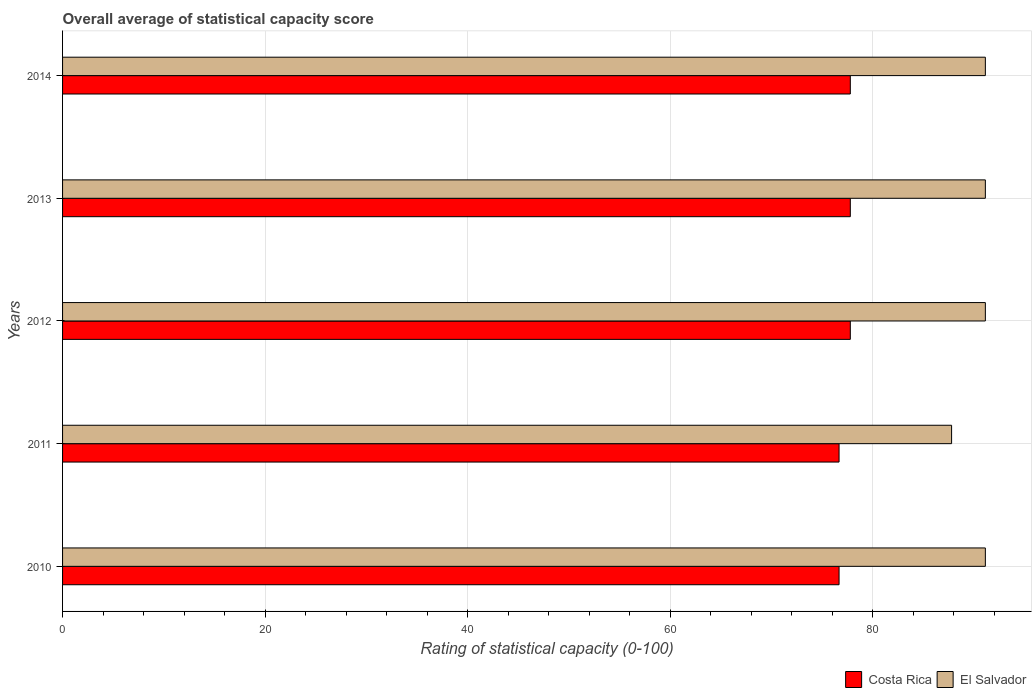How many groups of bars are there?
Make the answer very short. 5. Are the number of bars on each tick of the Y-axis equal?
Ensure brevity in your answer.  Yes. In how many cases, is the number of bars for a given year not equal to the number of legend labels?
Make the answer very short. 0. What is the rating of statistical capacity in El Salvador in 2013?
Give a very brief answer. 91.11. Across all years, what is the maximum rating of statistical capacity in El Salvador?
Give a very brief answer. 91.11. Across all years, what is the minimum rating of statistical capacity in Costa Rica?
Your response must be concise. 76.67. In which year was the rating of statistical capacity in Costa Rica maximum?
Your answer should be very brief. 2012. In which year was the rating of statistical capacity in Costa Rica minimum?
Ensure brevity in your answer.  2010. What is the total rating of statistical capacity in El Salvador in the graph?
Ensure brevity in your answer.  452.22. What is the difference between the rating of statistical capacity in El Salvador in 2014 and the rating of statistical capacity in Costa Rica in 2013?
Your response must be concise. 13.33. What is the average rating of statistical capacity in El Salvador per year?
Your response must be concise. 90.44. In the year 2014, what is the difference between the rating of statistical capacity in Costa Rica and rating of statistical capacity in El Salvador?
Provide a succinct answer. -13.33. In how many years, is the rating of statistical capacity in Costa Rica greater than 88 ?
Give a very brief answer. 0. What is the ratio of the rating of statistical capacity in Costa Rica in 2013 to that in 2014?
Your answer should be compact. 1. Is the difference between the rating of statistical capacity in Costa Rica in 2011 and 2014 greater than the difference between the rating of statistical capacity in El Salvador in 2011 and 2014?
Make the answer very short. Yes. What is the difference between the highest and the lowest rating of statistical capacity in El Salvador?
Ensure brevity in your answer.  3.33. In how many years, is the rating of statistical capacity in Costa Rica greater than the average rating of statistical capacity in Costa Rica taken over all years?
Offer a terse response. 3. Is the sum of the rating of statistical capacity in El Salvador in 2011 and 2014 greater than the maximum rating of statistical capacity in Costa Rica across all years?
Keep it short and to the point. Yes. What does the 1st bar from the top in 2014 represents?
Offer a terse response. El Salvador. What does the 1st bar from the bottom in 2011 represents?
Offer a terse response. Costa Rica. Are all the bars in the graph horizontal?
Make the answer very short. Yes. Are the values on the major ticks of X-axis written in scientific E-notation?
Keep it short and to the point. No. Does the graph contain any zero values?
Provide a succinct answer. No. Does the graph contain grids?
Your answer should be very brief. Yes. How many legend labels are there?
Offer a terse response. 2. How are the legend labels stacked?
Keep it short and to the point. Horizontal. What is the title of the graph?
Make the answer very short. Overall average of statistical capacity score. What is the label or title of the X-axis?
Provide a succinct answer. Rating of statistical capacity (0-100). What is the Rating of statistical capacity (0-100) in Costa Rica in 2010?
Your answer should be compact. 76.67. What is the Rating of statistical capacity (0-100) of El Salvador in 2010?
Provide a succinct answer. 91.11. What is the Rating of statistical capacity (0-100) in Costa Rica in 2011?
Make the answer very short. 76.67. What is the Rating of statistical capacity (0-100) in El Salvador in 2011?
Provide a succinct answer. 87.78. What is the Rating of statistical capacity (0-100) of Costa Rica in 2012?
Ensure brevity in your answer.  77.78. What is the Rating of statistical capacity (0-100) in El Salvador in 2012?
Provide a succinct answer. 91.11. What is the Rating of statistical capacity (0-100) of Costa Rica in 2013?
Offer a very short reply. 77.78. What is the Rating of statistical capacity (0-100) in El Salvador in 2013?
Your response must be concise. 91.11. What is the Rating of statistical capacity (0-100) of Costa Rica in 2014?
Your answer should be compact. 77.78. What is the Rating of statistical capacity (0-100) of El Salvador in 2014?
Make the answer very short. 91.11. Across all years, what is the maximum Rating of statistical capacity (0-100) of Costa Rica?
Make the answer very short. 77.78. Across all years, what is the maximum Rating of statistical capacity (0-100) of El Salvador?
Provide a succinct answer. 91.11. Across all years, what is the minimum Rating of statistical capacity (0-100) in Costa Rica?
Give a very brief answer. 76.67. Across all years, what is the minimum Rating of statistical capacity (0-100) of El Salvador?
Provide a succinct answer. 87.78. What is the total Rating of statistical capacity (0-100) in Costa Rica in the graph?
Your answer should be compact. 386.67. What is the total Rating of statistical capacity (0-100) of El Salvador in the graph?
Your answer should be compact. 452.22. What is the difference between the Rating of statistical capacity (0-100) of Costa Rica in 2010 and that in 2012?
Your response must be concise. -1.11. What is the difference between the Rating of statistical capacity (0-100) of Costa Rica in 2010 and that in 2013?
Give a very brief answer. -1.11. What is the difference between the Rating of statistical capacity (0-100) in El Salvador in 2010 and that in 2013?
Keep it short and to the point. 0. What is the difference between the Rating of statistical capacity (0-100) in Costa Rica in 2010 and that in 2014?
Keep it short and to the point. -1.11. What is the difference between the Rating of statistical capacity (0-100) in El Salvador in 2010 and that in 2014?
Provide a short and direct response. 0. What is the difference between the Rating of statistical capacity (0-100) of Costa Rica in 2011 and that in 2012?
Your answer should be compact. -1.11. What is the difference between the Rating of statistical capacity (0-100) of Costa Rica in 2011 and that in 2013?
Give a very brief answer. -1.11. What is the difference between the Rating of statistical capacity (0-100) of Costa Rica in 2011 and that in 2014?
Ensure brevity in your answer.  -1.11. What is the difference between the Rating of statistical capacity (0-100) of El Salvador in 2011 and that in 2014?
Your answer should be compact. -3.33. What is the difference between the Rating of statistical capacity (0-100) in Costa Rica in 2012 and that in 2013?
Make the answer very short. 0. What is the difference between the Rating of statistical capacity (0-100) of El Salvador in 2012 and that in 2013?
Make the answer very short. 0. What is the difference between the Rating of statistical capacity (0-100) in El Salvador in 2012 and that in 2014?
Give a very brief answer. 0. What is the difference between the Rating of statistical capacity (0-100) in Costa Rica in 2010 and the Rating of statistical capacity (0-100) in El Salvador in 2011?
Offer a very short reply. -11.11. What is the difference between the Rating of statistical capacity (0-100) of Costa Rica in 2010 and the Rating of statistical capacity (0-100) of El Salvador in 2012?
Provide a succinct answer. -14.44. What is the difference between the Rating of statistical capacity (0-100) in Costa Rica in 2010 and the Rating of statistical capacity (0-100) in El Salvador in 2013?
Offer a very short reply. -14.44. What is the difference between the Rating of statistical capacity (0-100) in Costa Rica in 2010 and the Rating of statistical capacity (0-100) in El Salvador in 2014?
Provide a short and direct response. -14.44. What is the difference between the Rating of statistical capacity (0-100) in Costa Rica in 2011 and the Rating of statistical capacity (0-100) in El Salvador in 2012?
Your answer should be compact. -14.44. What is the difference between the Rating of statistical capacity (0-100) in Costa Rica in 2011 and the Rating of statistical capacity (0-100) in El Salvador in 2013?
Offer a terse response. -14.44. What is the difference between the Rating of statistical capacity (0-100) of Costa Rica in 2011 and the Rating of statistical capacity (0-100) of El Salvador in 2014?
Your answer should be very brief. -14.44. What is the difference between the Rating of statistical capacity (0-100) of Costa Rica in 2012 and the Rating of statistical capacity (0-100) of El Salvador in 2013?
Give a very brief answer. -13.33. What is the difference between the Rating of statistical capacity (0-100) in Costa Rica in 2012 and the Rating of statistical capacity (0-100) in El Salvador in 2014?
Keep it short and to the point. -13.33. What is the difference between the Rating of statistical capacity (0-100) of Costa Rica in 2013 and the Rating of statistical capacity (0-100) of El Salvador in 2014?
Keep it short and to the point. -13.33. What is the average Rating of statistical capacity (0-100) in Costa Rica per year?
Your answer should be very brief. 77.33. What is the average Rating of statistical capacity (0-100) of El Salvador per year?
Offer a very short reply. 90.44. In the year 2010, what is the difference between the Rating of statistical capacity (0-100) in Costa Rica and Rating of statistical capacity (0-100) in El Salvador?
Your answer should be very brief. -14.44. In the year 2011, what is the difference between the Rating of statistical capacity (0-100) in Costa Rica and Rating of statistical capacity (0-100) in El Salvador?
Provide a succinct answer. -11.11. In the year 2012, what is the difference between the Rating of statistical capacity (0-100) of Costa Rica and Rating of statistical capacity (0-100) of El Salvador?
Your answer should be very brief. -13.33. In the year 2013, what is the difference between the Rating of statistical capacity (0-100) in Costa Rica and Rating of statistical capacity (0-100) in El Salvador?
Give a very brief answer. -13.33. In the year 2014, what is the difference between the Rating of statistical capacity (0-100) in Costa Rica and Rating of statistical capacity (0-100) in El Salvador?
Your answer should be compact. -13.33. What is the ratio of the Rating of statistical capacity (0-100) of El Salvador in 2010 to that in 2011?
Your answer should be compact. 1.04. What is the ratio of the Rating of statistical capacity (0-100) of Costa Rica in 2010 to that in 2012?
Your answer should be very brief. 0.99. What is the ratio of the Rating of statistical capacity (0-100) in El Salvador in 2010 to that in 2012?
Your answer should be compact. 1. What is the ratio of the Rating of statistical capacity (0-100) in Costa Rica in 2010 to that in 2013?
Give a very brief answer. 0.99. What is the ratio of the Rating of statistical capacity (0-100) of El Salvador in 2010 to that in 2013?
Your response must be concise. 1. What is the ratio of the Rating of statistical capacity (0-100) in Costa Rica in 2010 to that in 2014?
Give a very brief answer. 0.99. What is the ratio of the Rating of statistical capacity (0-100) of El Salvador in 2010 to that in 2014?
Make the answer very short. 1. What is the ratio of the Rating of statistical capacity (0-100) in Costa Rica in 2011 to that in 2012?
Give a very brief answer. 0.99. What is the ratio of the Rating of statistical capacity (0-100) of El Salvador in 2011 to that in 2012?
Make the answer very short. 0.96. What is the ratio of the Rating of statistical capacity (0-100) in Costa Rica in 2011 to that in 2013?
Your answer should be very brief. 0.99. What is the ratio of the Rating of statistical capacity (0-100) of El Salvador in 2011 to that in 2013?
Offer a terse response. 0.96. What is the ratio of the Rating of statistical capacity (0-100) of Costa Rica in 2011 to that in 2014?
Offer a very short reply. 0.99. What is the ratio of the Rating of statistical capacity (0-100) of El Salvador in 2011 to that in 2014?
Ensure brevity in your answer.  0.96. What is the ratio of the Rating of statistical capacity (0-100) in Costa Rica in 2012 to that in 2013?
Keep it short and to the point. 1. What is the ratio of the Rating of statistical capacity (0-100) in El Salvador in 2012 to that in 2013?
Provide a succinct answer. 1. What is the ratio of the Rating of statistical capacity (0-100) of Costa Rica in 2012 to that in 2014?
Give a very brief answer. 1. What is the ratio of the Rating of statistical capacity (0-100) in Costa Rica in 2013 to that in 2014?
Your answer should be compact. 1. What is the ratio of the Rating of statistical capacity (0-100) in El Salvador in 2013 to that in 2014?
Keep it short and to the point. 1. What is the difference between the highest and the second highest Rating of statistical capacity (0-100) of Costa Rica?
Ensure brevity in your answer.  0. What is the difference between the highest and the second highest Rating of statistical capacity (0-100) of El Salvador?
Make the answer very short. 0. What is the difference between the highest and the lowest Rating of statistical capacity (0-100) in El Salvador?
Offer a very short reply. 3.33. 